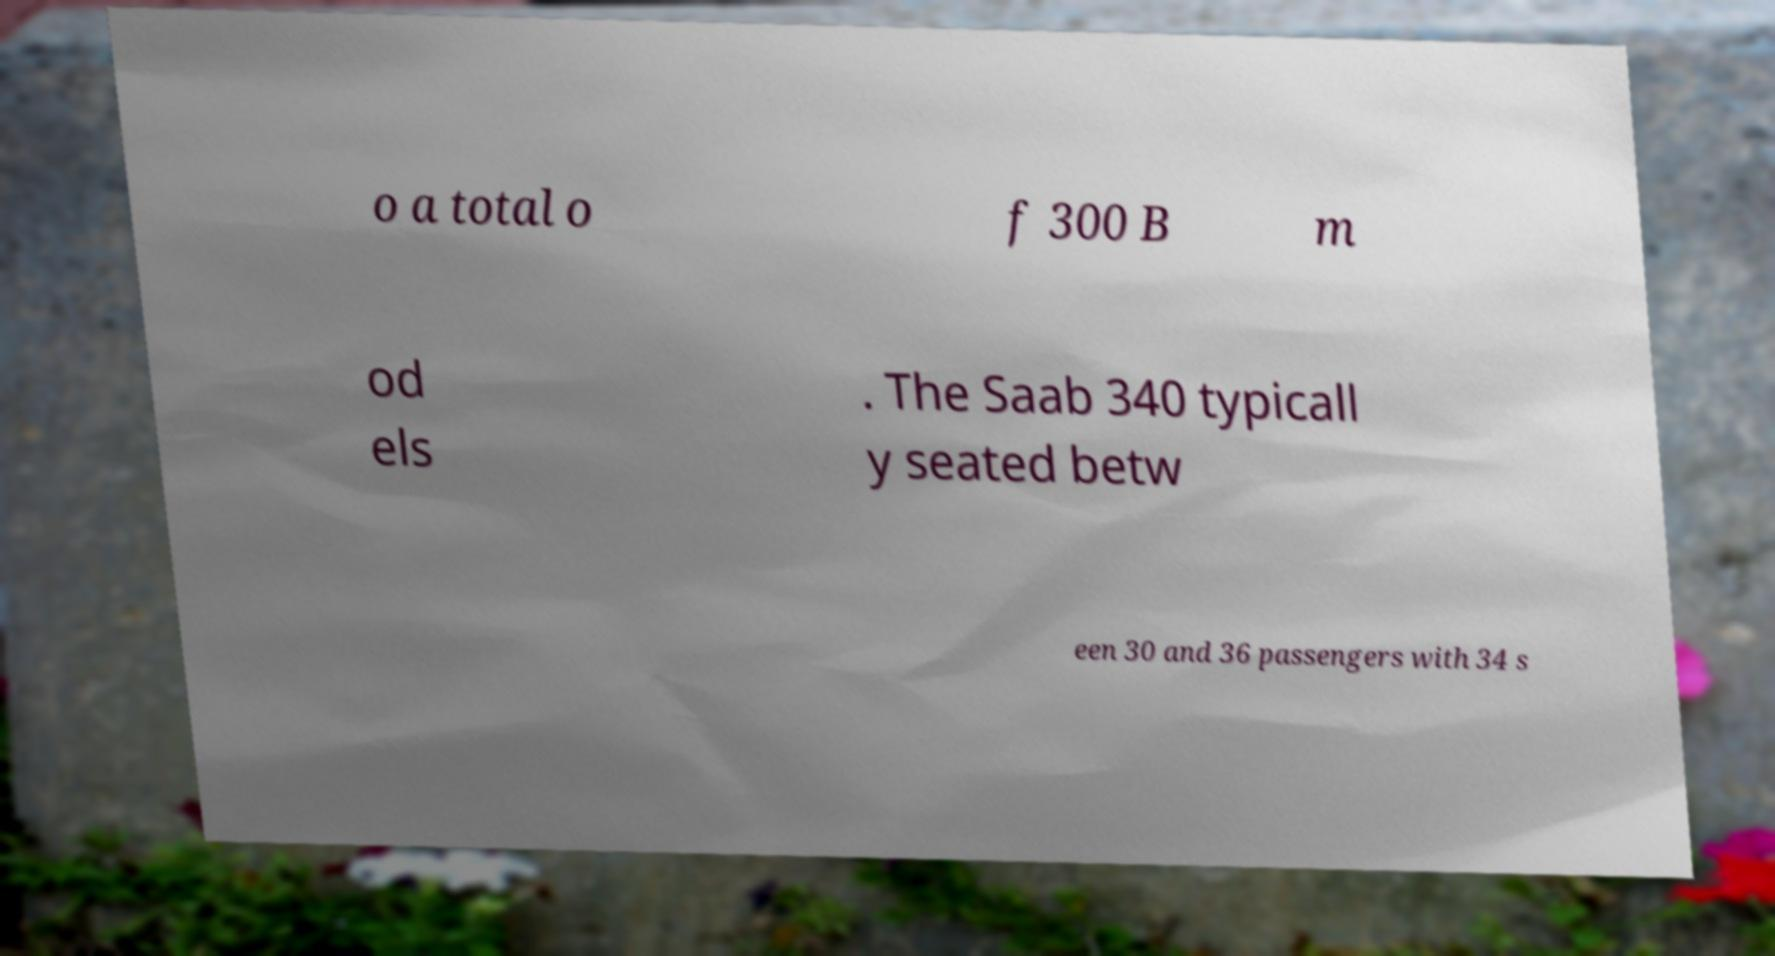I need the written content from this picture converted into text. Can you do that? o a total o f 300 B m od els . The Saab 340 typicall y seated betw een 30 and 36 passengers with 34 s 